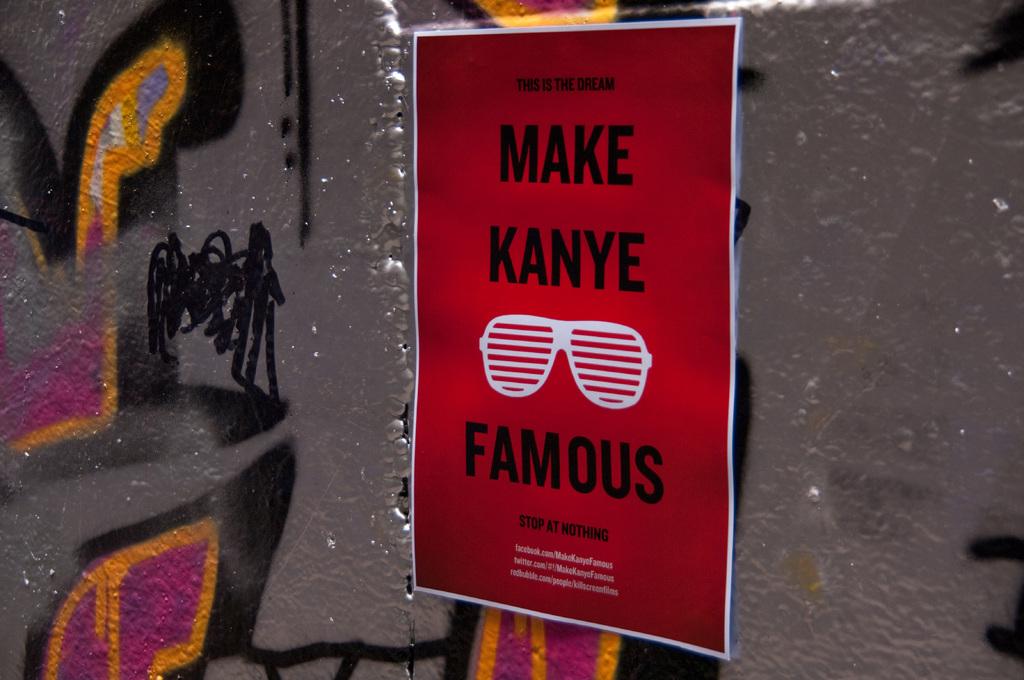Who is wanting to be famous?
Offer a terse response. Kanye. What is the tag line written on this board?
Provide a short and direct response. Make kanye famous. 